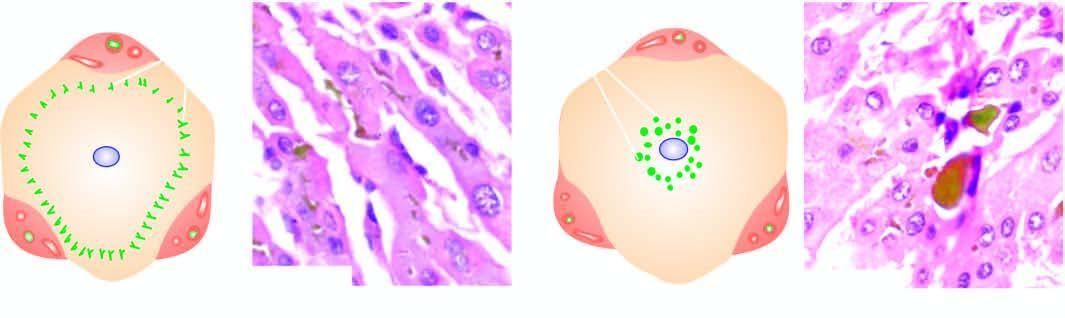s intrahepatic cholestasis characterised by elongated bile plugs in the canaliculi of hepatocytes at the periphery of the lobule?
Answer the question using a single word or phrase. Yes 